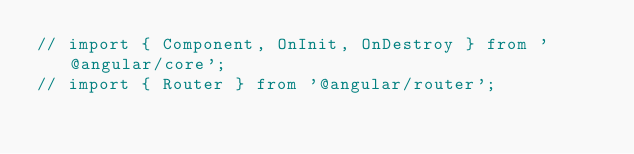Convert code to text. <code><loc_0><loc_0><loc_500><loc_500><_TypeScript_>// import { Component, OnInit, OnDestroy } from '@angular/core';
// import { Router } from '@angular/router';</code> 